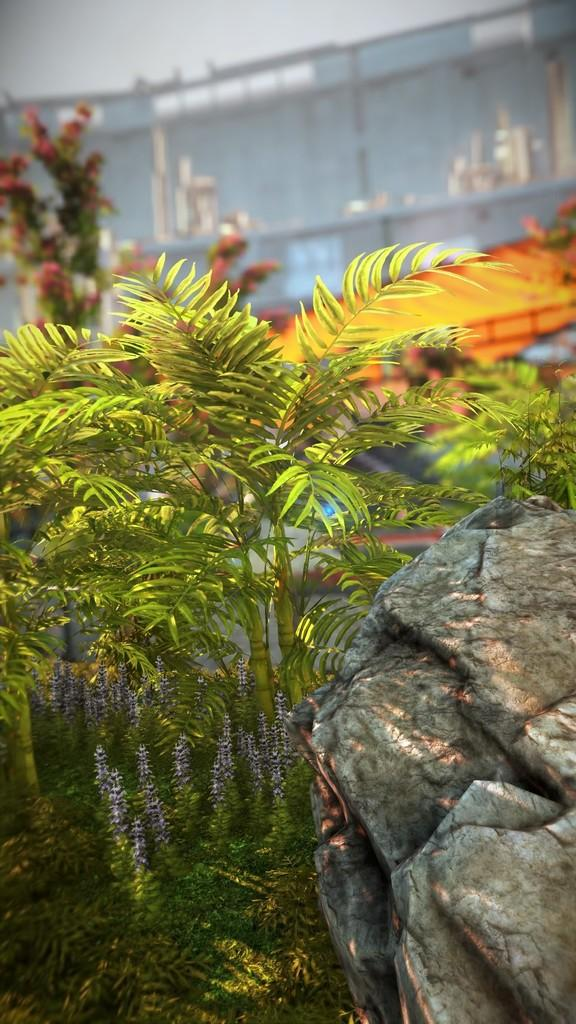What type of vegetation is present in the image? There are trees with branches and leaves in the image. Can these trees be classified as a specific type of living organism? Yes, these trees may be considered as plants. What other object can be seen in the image? There is a rock in the image. What can be seen in the background of the image? There is a building in the background of the image. What type of spoon is hanging from the tree in the image? There is no spoon present in the image; it only features trees, a rock, and a building in the background. 